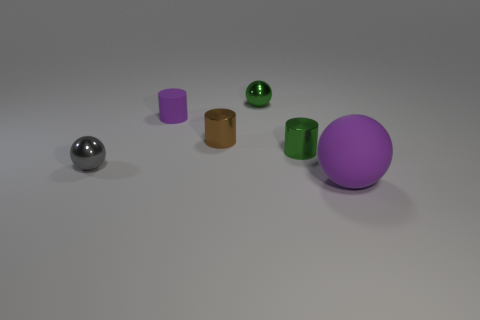Subtract all brown cylinders. How many cylinders are left? 2 Add 3 tiny green metal things. How many objects exist? 9 Subtract 1 cylinders. How many cylinders are left? 2 Subtract all green cylinders. How many cylinders are left? 2 Subtract all tiny green metallic cylinders. Subtract all brown cylinders. How many objects are left? 4 Add 5 tiny green metal balls. How many tiny green metal balls are left? 6 Add 1 large purple things. How many large purple things exist? 2 Subtract 0 brown balls. How many objects are left? 6 Subtract all red spheres. Subtract all purple blocks. How many spheres are left? 3 